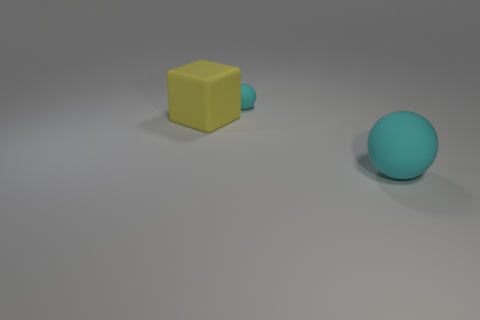How many other objects are there of the same size as the yellow cube?
Your response must be concise. 1. The large thing left of the big object right of the cyan rubber ball that is on the left side of the big cyan object is what shape?
Provide a short and direct response. Cube. The matte object that is both behind the big cyan rubber object and in front of the small cyan rubber object has what shape?
Your response must be concise. Cube. What number of things are small purple matte things or rubber objects right of the large yellow matte object?
Keep it short and to the point. 2. What number of other objects are there of the same shape as the large yellow thing?
Give a very brief answer. 0. There is a matte thing that is both right of the large yellow rubber cube and in front of the small sphere; how big is it?
Your response must be concise. Large. What number of shiny things are either big cyan spheres or yellow blocks?
Give a very brief answer. 0. Do the rubber thing behind the large yellow cube and the large thing on the left side of the big cyan rubber sphere have the same shape?
Provide a succinct answer. No. Are there any big blue cylinders that have the same material as the yellow block?
Provide a succinct answer. No. What color is the big matte ball?
Give a very brief answer. Cyan. 